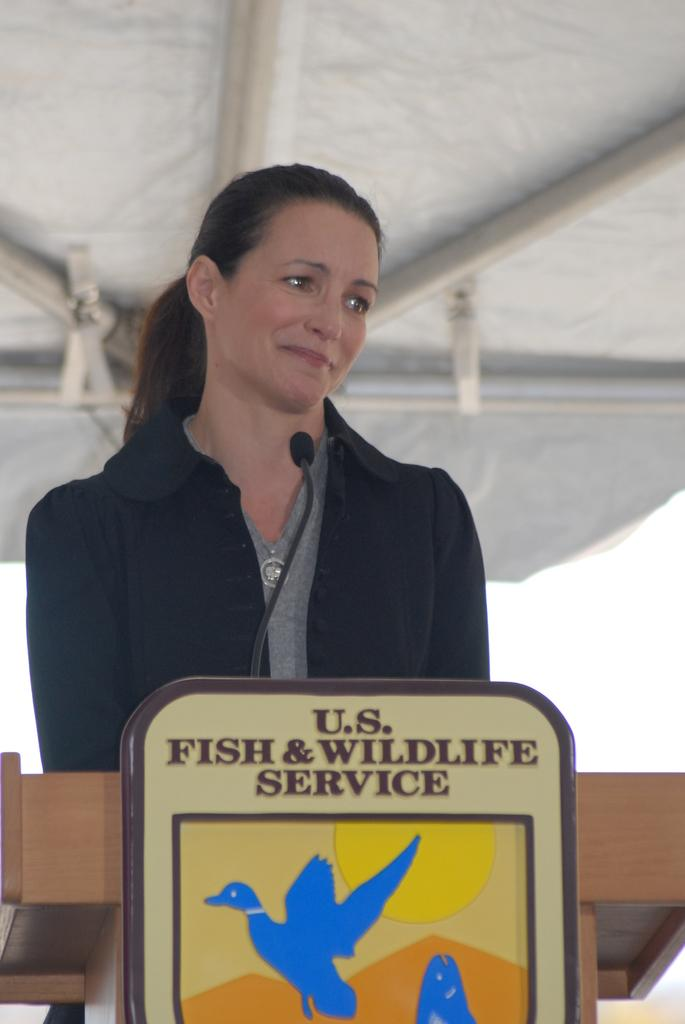Who or what is present in the image? There is a person in the image. What is the person wearing? The person is wearing a black dress. What other objects can be seen in the image? There is a wooden block and a microphone in the image. What type of pear is being used as a stop sign in the image? There is no pear or stop sign present in the image. 